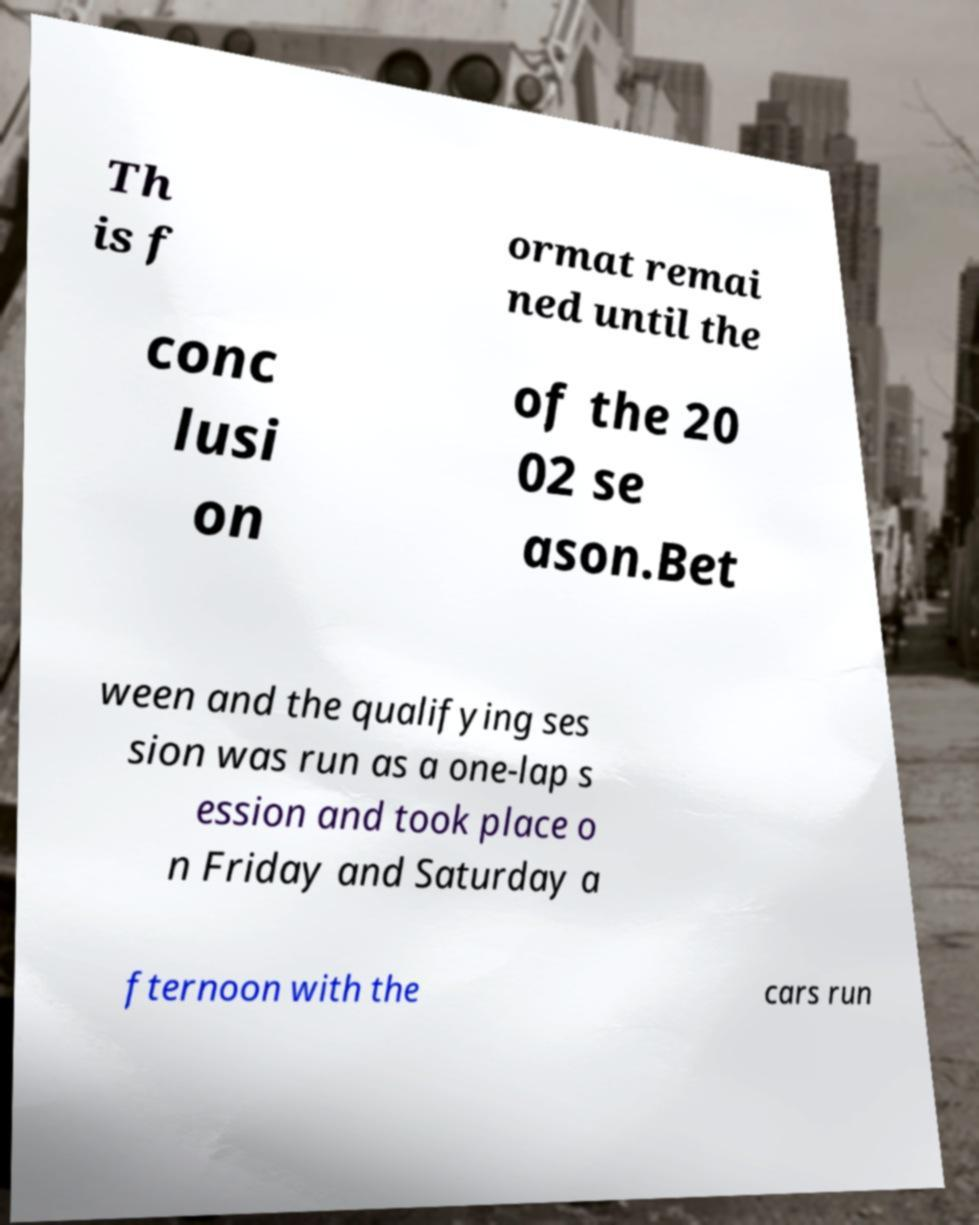Could you assist in decoding the text presented in this image and type it out clearly? Th is f ormat remai ned until the conc lusi on of the 20 02 se ason.Bet ween and the qualifying ses sion was run as a one-lap s ession and took place o n Friday and Saturday a fternoon with the cars run 